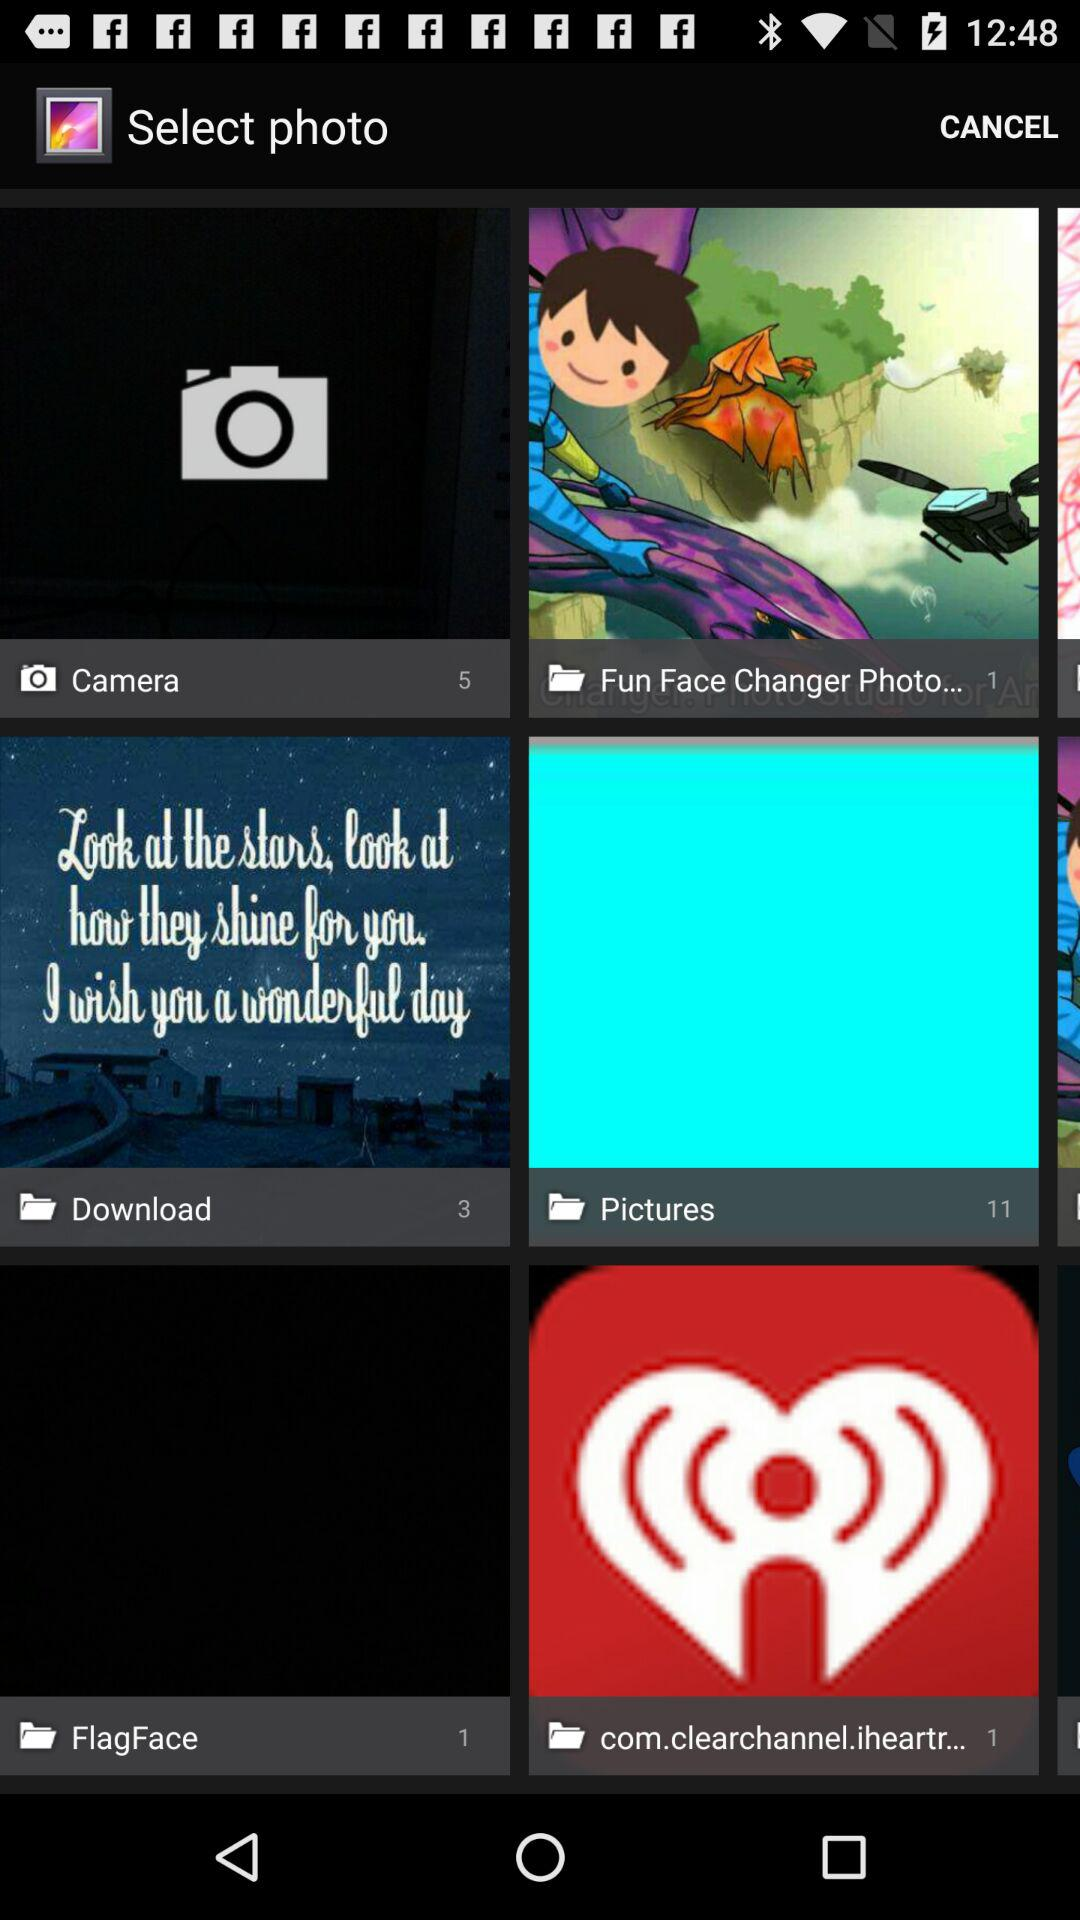What is the number of images in the "Fun Face Changer Photo..." folder? The number of images in the "Fun Face Changer Photo..." folder is 1. 